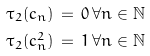Convert formula to latex. <formula><loc_0><loc_0><loc_500><loc_500>\tau _ { 2 } ( c _ { n } ) \, & = \, 0 \, \forall n \in { \mathbb { N } } \\ \tau _ { 2 } ( c _ { n } ^ { 2 } ) \, & = \, 1 \, \forall n \in { \mathbb { N } }</formula> 